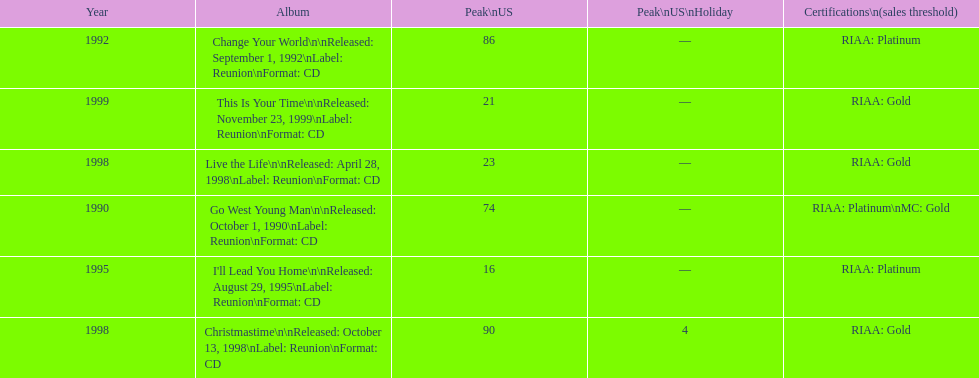What michael w smith album was released before his christmastime album? Live the Life. 